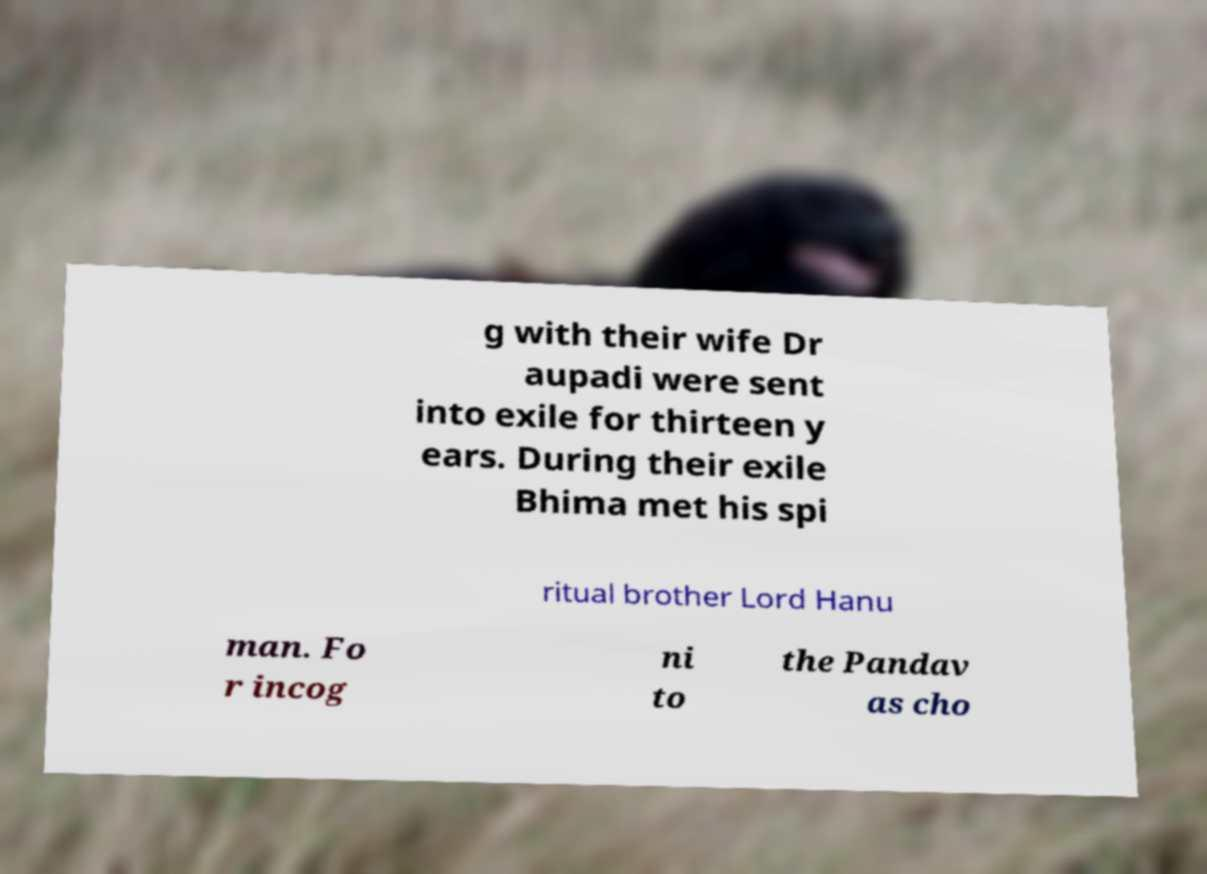I need the written content from this picture converted into text. Can you do that? g with their wife Dr aupadi were sent into exile for thirteen y ears. During their exile Bhima met his spi ritual brother Lord Hanu man. Fo r incog ni to the Pandav as cho 